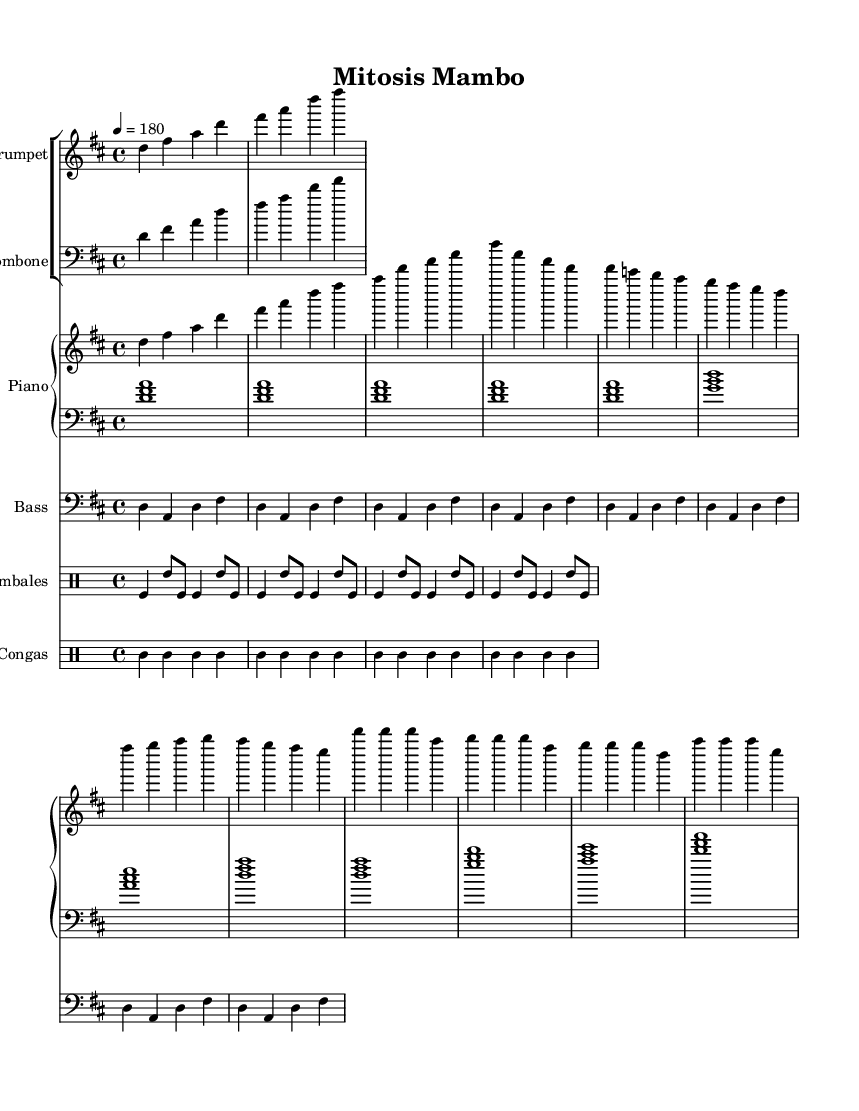What is the key signature of this music? The key signature is indicated at the beginning of the staff. It shows two sharps, which corresponds to D major.
Answer: D major What is the time signature of this piece? The time signature is shown at the beginning of the sheet music where it says 4/4. This means there are four beats in each measure and a quarter note gets one beat.
Answer: 4/4 What is the tempo marking of "Mitosis Mambo"? The tempo marking is located near the beginning of the score and indicates "4 = 180", meaning there are 180 quarter notes per minute.
Answer: 180 How many measures are in the intro section? The intro section is composed of four measures, which can be counted by looking at the distinct musical phrases at the start of the piece.
Answer: 4 What instruments are featured in this arrangement? By examining the score, we can see staff groups designated for the trumpet, trombone, piano, bass, timbales, and congas indicating the instrument arrangement.
Answer: Trumpet, Trombone, Piano, Bass, Timbales, Congas What is the primary rhythmic pattern used in the congas part? The congas part consists of a repeated pattern throughout the measures which can be analyzed by looking at the notation of the drum staff. It follows a sequence of high and low conga sounds.
Answer: High and low conga sounds Which section features the chorus? The chorus can be identified by analyzing the musical structure and phrasing. It appears after the verses and is labeled in the score, which denotes changes in the musical theme.
Answer: After the verse 